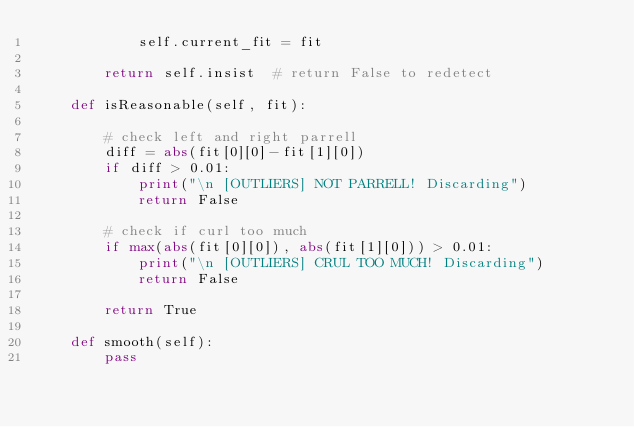Convert code to text. <code><loc_0><loc_0><loc_500><loc_500><_Python_>            self.current_fit = fit

        return self.insist  # return False to redetect

    def isReasonable(self, fit):

        # check left and right parrell
        diff = abs(fit[0][0]-fit[1][0])
        if diff > 0.01:
            print("\n [OUTLIERS] NOT PARRELL! Discarding")
            return False

        # check if curl too much
        if max(abs(fit[0][0]), abs(fit[1][0])) > 0.01:
            print("\n [OUTLIERS] CRUL TOO MUCH! Discarding")
            return False

        return True

    def smooth(self):
        pass



</code> 